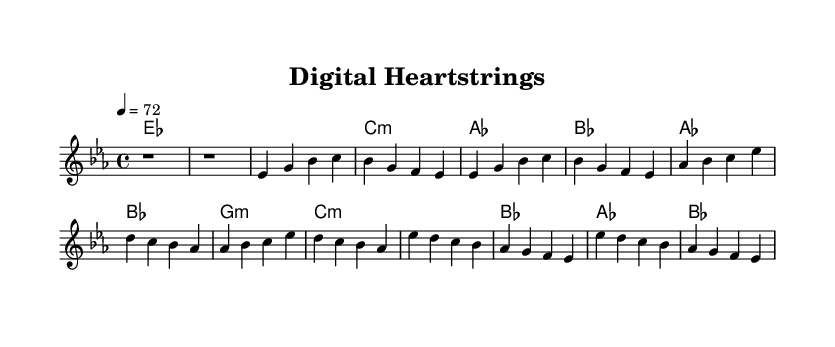What is the key signature of this music? The key signature indicates that the piece is in E flat major, as it has three flats (B flat, E flat, and A flat). This can be identified at the beginning of the sheet music where the flats are placed.
Answer: E flat major What is the time signature of this music? The time signature is found at the beginning of the sheet music, showing how many beats are in a measure. In this case, 4/4 indicates there are four beats per measure.
Answer: 4/4 What is the tempo marking for this piece? The tempo marking specifies the speed at which the piece should be played. It is indicated at the start and reads "4 = 72", meaning each quarter note gets 72 beats per minute.
Answer: 72 What is the structure of the song? The structure can be identified by analyzing the order of sections in the music. It starts with an intro, followed by verses, a chorus, and a bridge, reflecting a common structure in songs.
Answer: Intro, Verse, Chorus, Bridge How many measures are in the melody? To determine the number of measures in the melody, we can count the individual groups divided by vertical lines on the score. The melody section comprises 8 measures in total.
Answer: 8 Which section has the highest pitch? To find the section with the highest pitch, we need to analyze the melody. The bridge section starts at E flat' and has ascending notes, indicating higher pitches than the other sections.
Answer: Bridge 